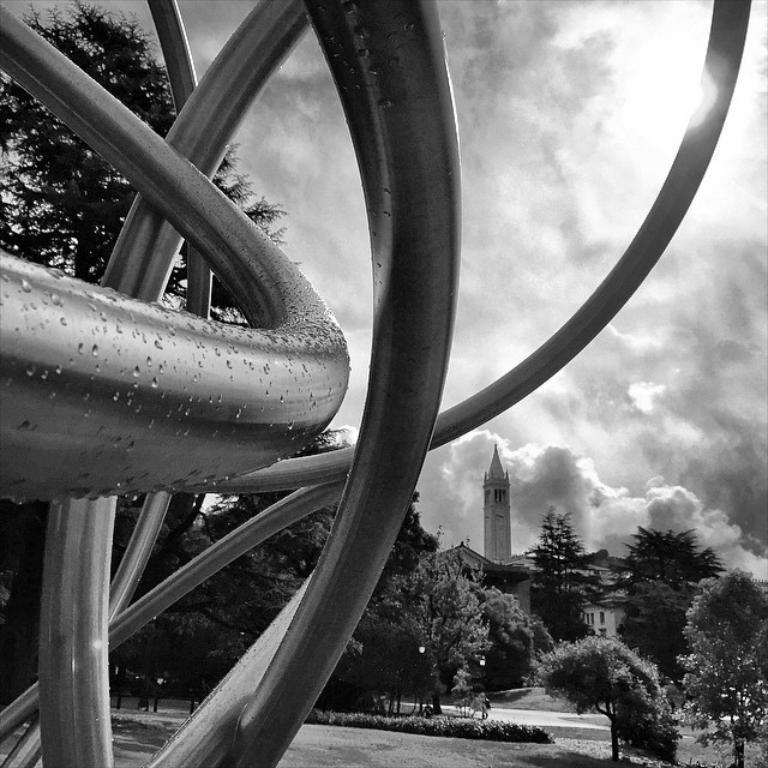Describe this image in one or two sentences. It is a black and white picture. Here we can see rods statue. Background we can see so many trees, buildings, tower, plants, grass, walkway, poles and cloudy sky. 